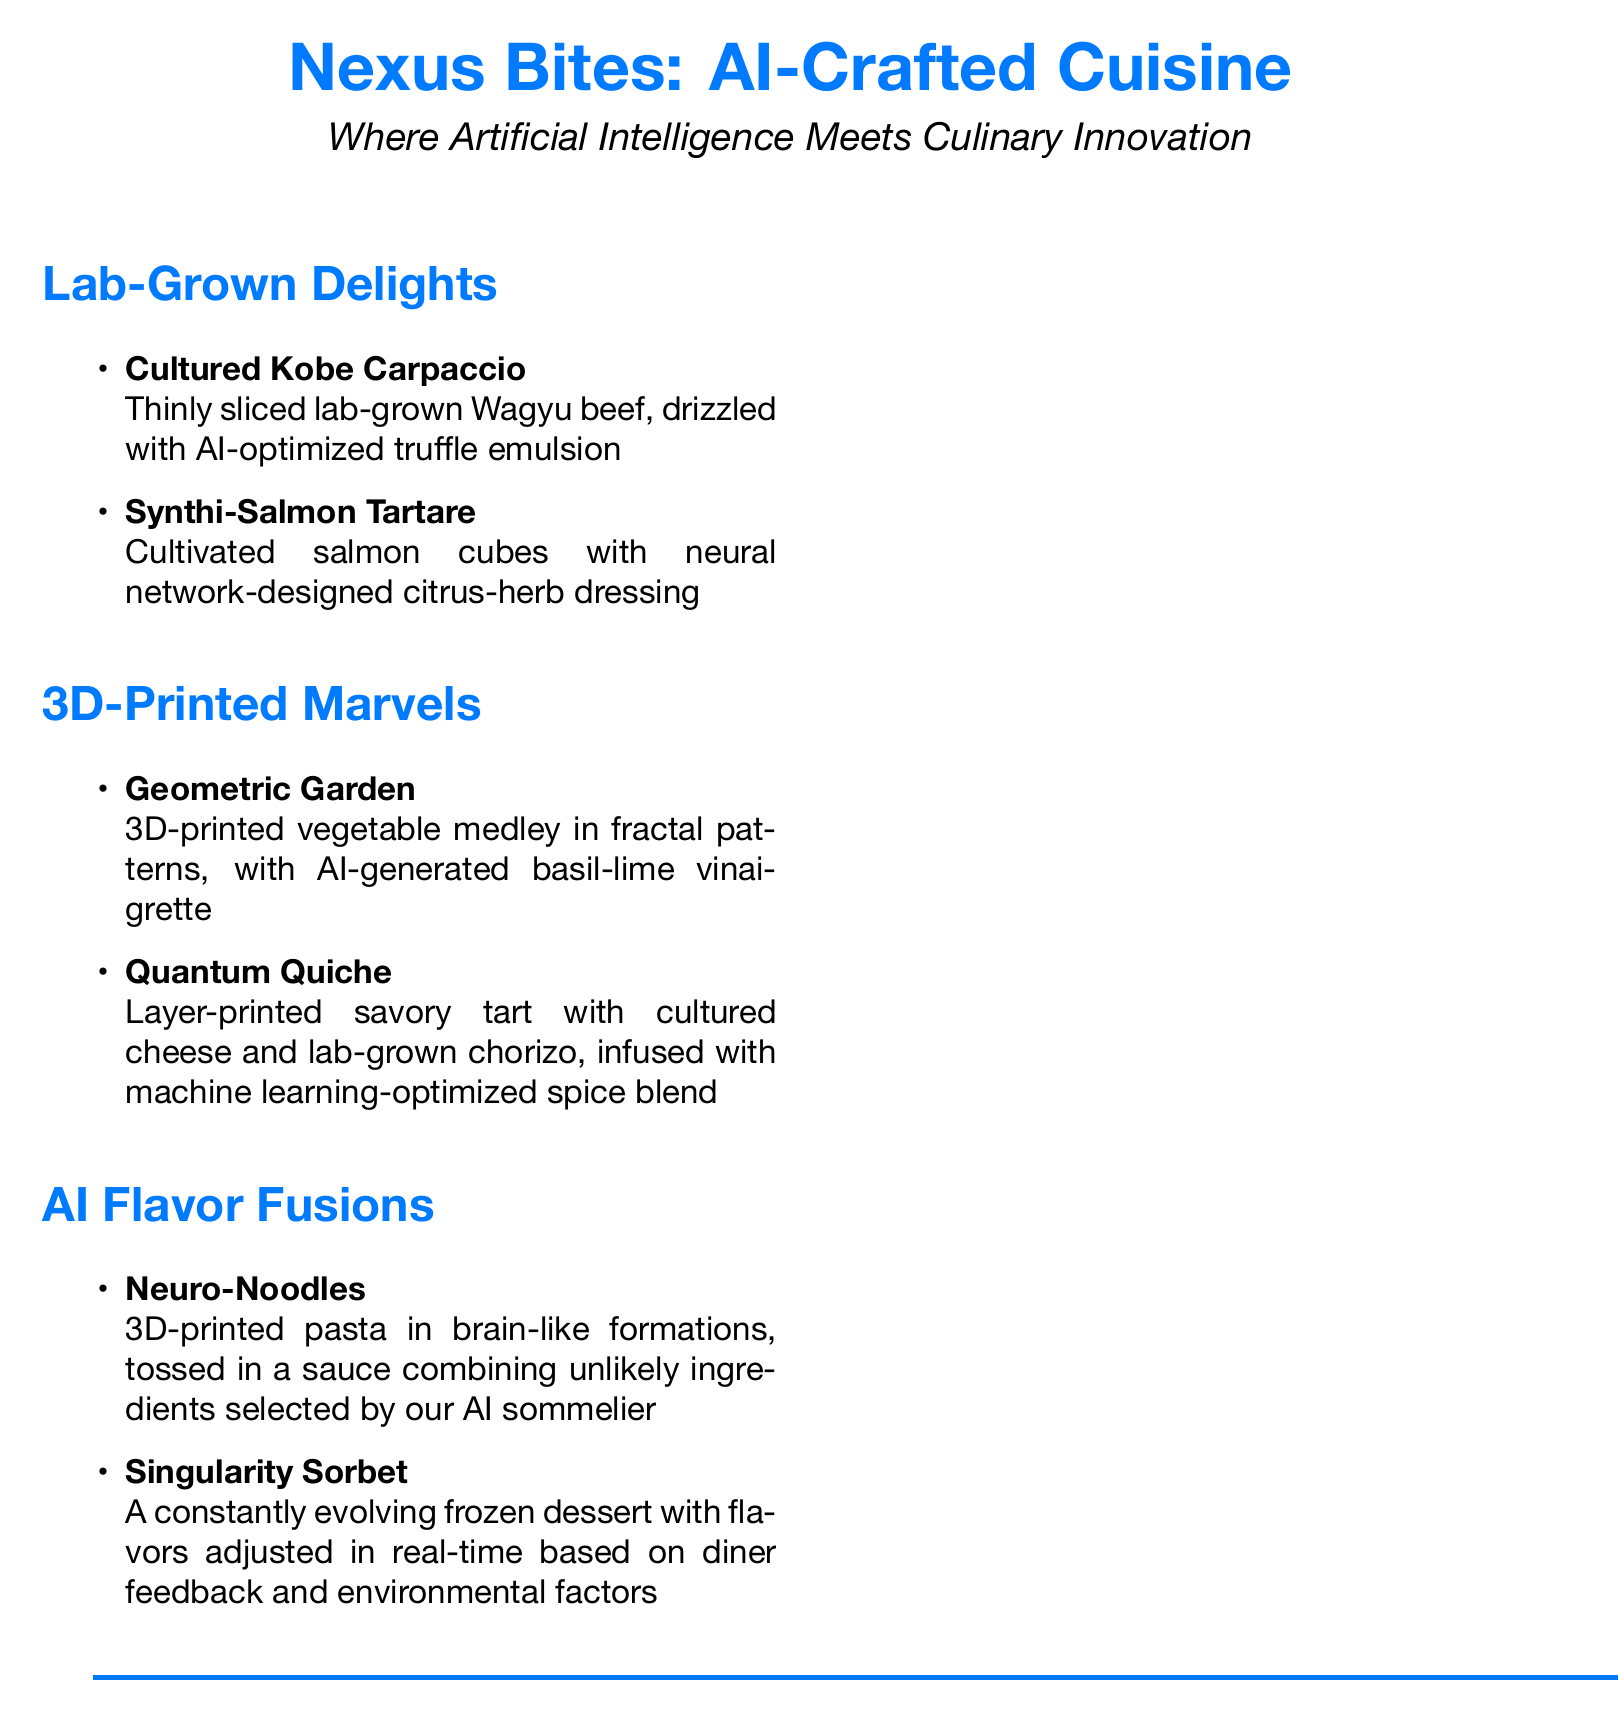What is the name of the first lab-grown dish? The first lab-grown dish is listed at the top of the Lab-Grown Delights section.
Answer: Cultured Kobe Carpaccio What type of fish is used in the Synthi-Salmon Tartare? This information is found in the description of the Synthi-Salmon Tartare dish.
Answer: Salmon What are the ingredients in the Quantum Quiche? The Quantum Quiche consists of specific components mentioned in the description.
Answer: Cultured cheese and lab-grown chorizo What is the main feature of the Singularity Sorbet? The main feature is described in the section where this dessert is presented.
Answer: Constantly evolving flavors How are the ingredients for Neuro-Noodles selected? This information is stated in the description of how the sauce is made for the Neuro-Noodles.
Answer: AI sommelier What is the ethical statement regarding food production? The ethical statement covers the production methods for the dishes included in the menu.
Answer: Sustainable, cruelty-free methods 